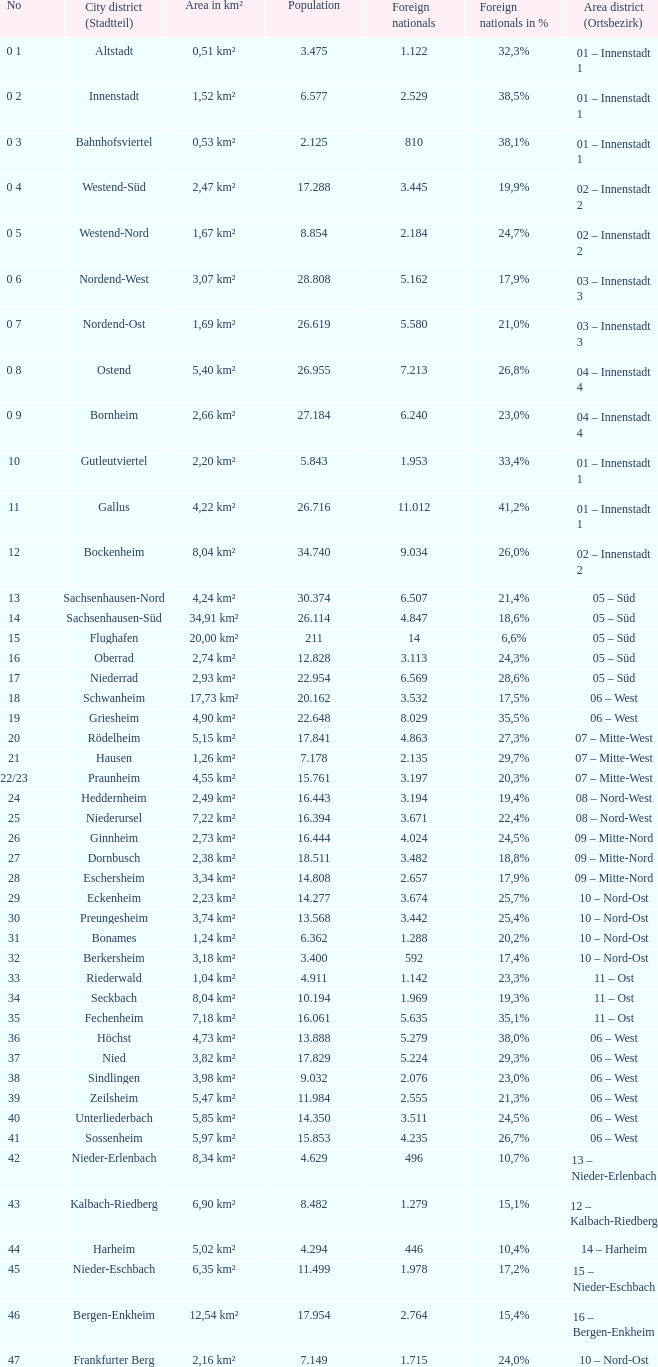911, what proportion was made up of foreign nationals? 1.0. 